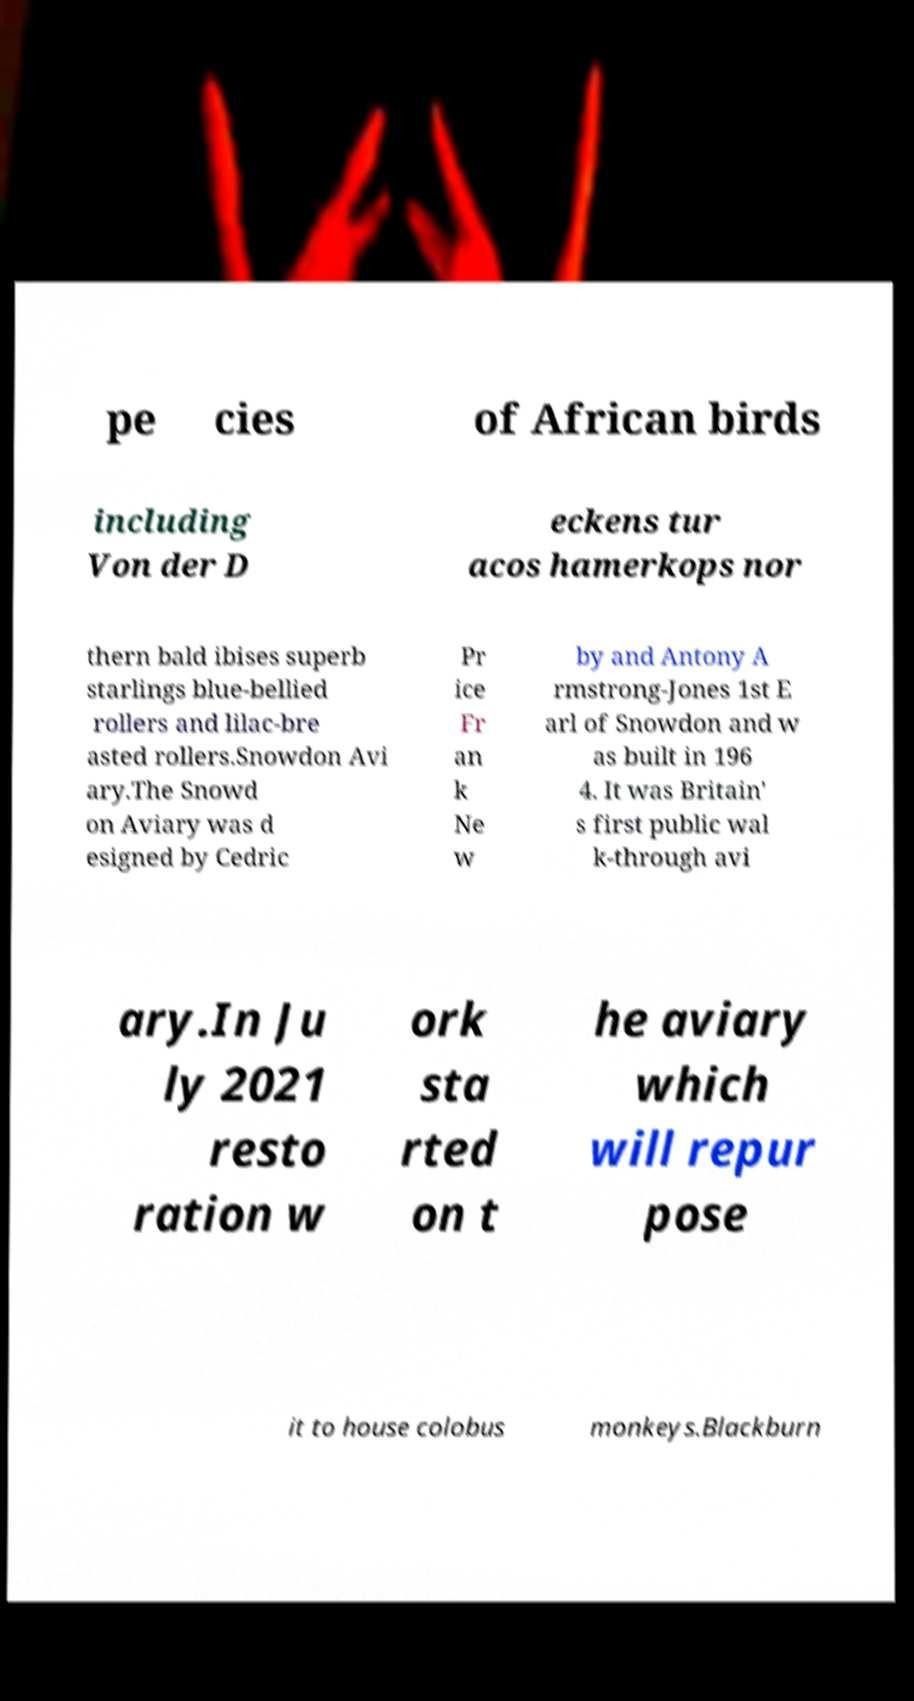There's text embedded in this image that I need extracted. Can you transcribe it verbatim? pe cies of African birds including Von der D eckens tur acos hamerkops nor thern bald ibises superb starlings blue-bellied rollers and lilac-bre asted rollers.Snowdon Avi ary.The Snowd on Aviary was d esigned by Cedric Pr ice Fr an k Ne w by and Antony A rmstrong-Jones 1st E arl of Snowdon and w as built in 196 4. It was Britain' s first public wal k-through avi ary.In Ju ly 2021 resto ration w ork sta rted on t he aviary which will repur pose it to house colobus monkeys.Blackburn 